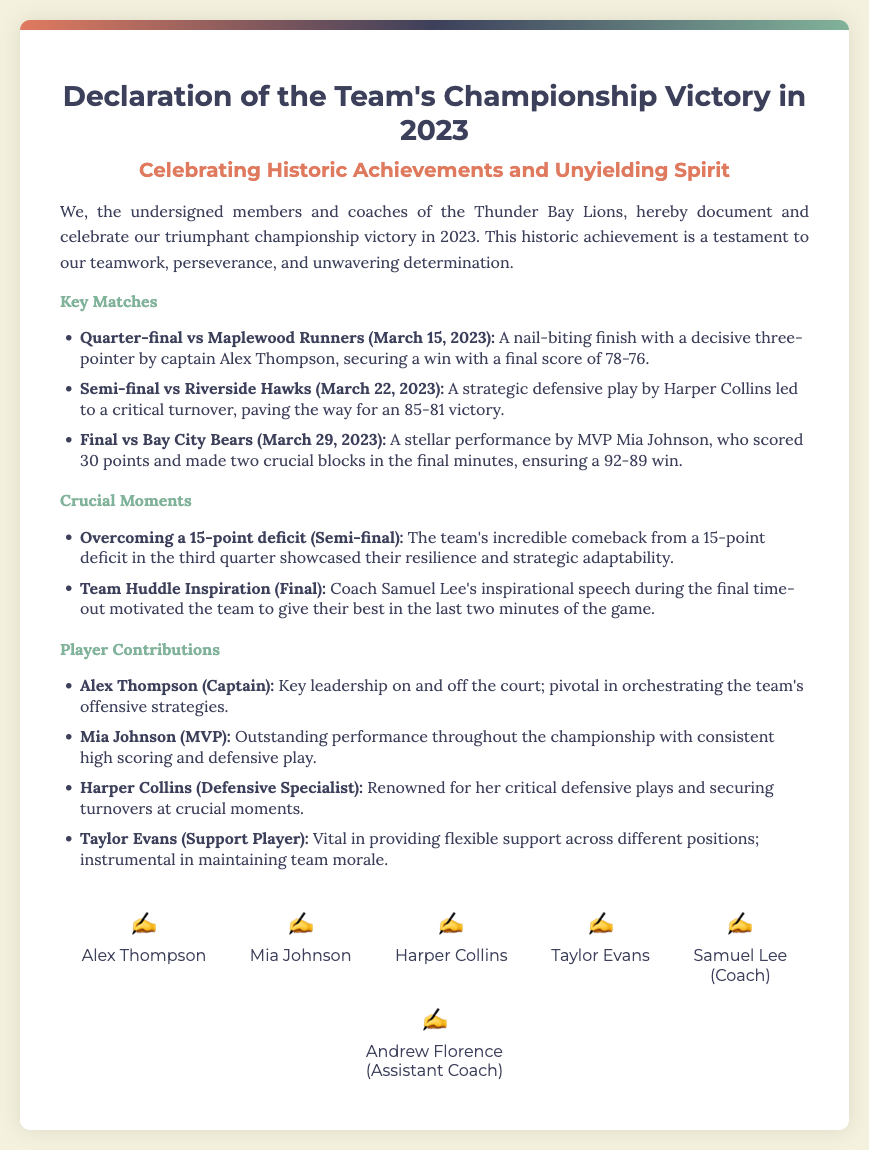What is the title of the document? The title is the main heading that introduces the topic of the document, which is the team's championship victory.
Answer: Declaration of the Team's Championship Victory in 2023 Who was the captain of the team? The captain is the player who often leads the team and is mentioned in the document, highlighting their role.
Answer: Alex Thompson What was the final score of the championship game? The final score is a key outcome mentioned in the document that summarizes the game's result.
Answer: 92-89 Which player was recognized as MVP? The MVP is the player who made the most significant contributions in the tournament, as stated in the document.
Answer: Mia Johnson What was the date of the semi-final match? The date of the semi-final is critical information related to the timeline of the matches played in the championship.
Answer: March 22, 2023 What was the team's largest comeback deficit? The comeback deficit indicates the challenge the team faced and their resilience during the matches.
Answer: 15-point Who made a decisive three-pointer in the quarter-final? This player is noted for a crucial moment that helped secure victory, emphasizing individual contributions.
Answer: Alex Thompson What was Coach Samuel Lee's role during the final? The role of the coach is integral to team performance and is indicated in the document as providing motivation.
Answer: Coach How many key matches are mentioned in the document? This number summarizes the total number of significant games described in the document.
Answer: Three 